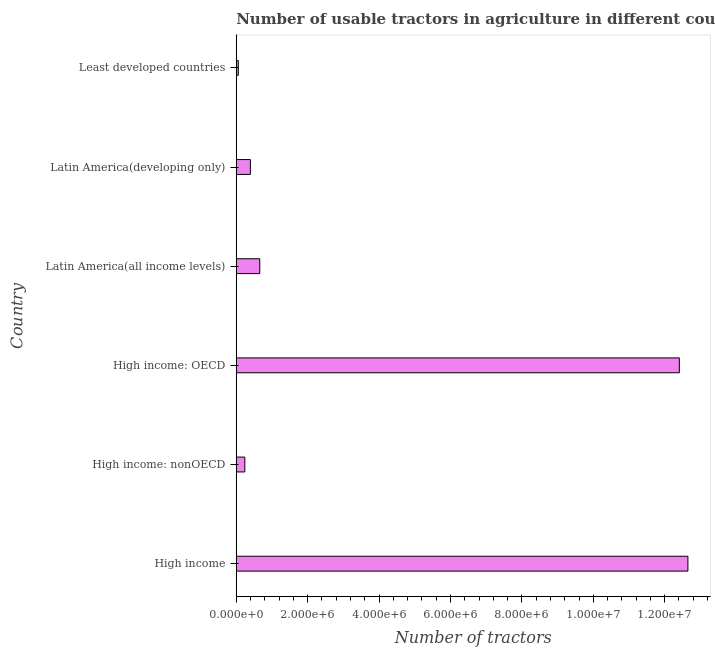Does the graph contain any zero values?
Make the answer very short. No. Does the graph contain grids?
Your response must be concise. No. What is the title of the graph?
Provide a succinct answer. Number of usable tractors in agriculture in different countries. What is the label or title of the X-axis?
Give a very brief answer. Number of tractors. What is the number of tractors in High income: nonOECD?
Offer a terse response. 2.40e+05. Across all countries, what is the maximum number of tractors?
Give a very brief answer. 1.26e+07. Across all countries, what is the minimum number of tractors?
Your response must be concise. 5.76e+04. In which country was the number of tractors maximum?
Your response must be concise. High income. In which country was the number of tractors minimum?
Provide a succinct answer. Least developed countries. What is the sum of the number of tractors?
Offer a very short reply. 2.64e+07. What is the difference between the number of tractors in High income: OECD and Latin America(all income levels)?
Provide a succinct answer. 1.18e+07. What is the average number of tractors per country?
Provide a short and direct response. 4.40e+06. What is the median number of tractors?
Your response must be concise. 5.27e+05. In how many countries, is the number of tractors greater than 400000 ?
Offer a very short reply. 3. What is the ratio of the number of tractors in High income: OECD to that in Latin America(developing only)?
Your response must be concise. 31.39. What is the difference between the highest and the second highest number of tractors?
Offer a terse response. 2.40e+05. What is the difference between the highest and the lowest number of tractors?
Provide a succinct answer. 1.26e+07. In how many countries, is the number of tractors greater than the average number of tractors taken over all countries?
Keep it short and to the point. 2. Are all the bars in the graph horizontal?
Ensure brevity in your answer.  Yes. How many countries are there in the graph?
Your answer should be compact. 6. Are the values on the major ticks of X-axis written in scientific E-notation?
Make the answer very short. Yes. What is the Number of tractors in High income?
Provide a short and direct response. 1.26e+07. What is the Number of tractors in High income: nonOECD?
Your answer should be very brief. 2.40e+05. What is the Number of tractors of High income: OECD?
Your response must be concise. 1.24e+07. What is the Number of tractors of Latin America(all income levels)?
Give a very brief answer. 6.59e+05. What is the Number of tractors of Latin America(developing only)?
Offer a very short reply. 3.95e+05. What is the Number of tractors in Least developed countries?
Provide a short and direct response. 5.76e+04. What is the difference between the Number of tractors in High income and High income: nonOECD?
Offer a very short reply. 1.24e+07. What is the difference between the Number of tractors in High income and High income: OECD?
Give a very brief answer. 2.40e+05. What is the difference between the Number of tractors in High income and Latin America(all income levels)?
Provide a short and direct response. 1.20e+07. What is the difference between the Number of tractors in High income and Latin America(developing only)?
Ensure brevity in your answer.  1.23e+07. What is the difference between the Number of tractors in High income and Least developed countries?
Provide a succinct answer. 1.26e+07. What is the difference between the Number of tractors in High income: nonOECD and High income: OECD?
Offer a very short reply. -1.22e+07. What is the difference between the Number of tractors in High income: nonOECD and Latin America(all income levels)?
Provide a short and direct response. -4.19e+05. What is the difference between the Number of tractors in High income: nonOECD and Latin America(developing only)?
Keep it short and to the point. -1.56e+05. What is the difference between the Number of tractors in High income: nonOECD and Least developed countries?
Give a very brief answer. 1.82e+05. What is the difference between the Number of tractors in High income: OECD and Latin America(all income levels)?
Your answer should be compact. 1.18e+07. What is the difference between the Number of tractors in High income: OECD and Latin America(developing only)?
Offer a terse response. 1.20e+07. What is the difference between the Number of tractors in High income: OECD and Least developed countries?
Provide a short and direct response. 1.24e+07. What is the difference between the Number of tractors in Latin America(all income levels) and Latin America(developing only)?
Give a very brief answer. 2.63e+05. What is the difference between the Number of tractors in Latin America(all income levels) and Least developed countries?
Provide a succinct answer. 6.01e+05. What is the difference between the Number of tractors in Latin America(developing only) and Least developed countries?
Offer a very short reply. 3.38e+05. What is the ratio of the Number of tractors in High income to that in High income: nonOECD?
Offer a very short reply. 52.77. What is the ratio of the Number of tractors in High income to that in High income: OECD?
Provide a succinct answer. 1.02. What is the ratio of the Number of tractors in High income to that in Latin America(all income levels)?
Your response must be concise. 19.2. What is the ratio of the Number of tractors in High income to that in Latin America(developing only)?
Ensure brevity in your answer.  32. What is the ratio of the Number of tractors in High income to that in Least developed countries?
Your answer should be very brief. 219.74. What is the ratio of the Number of tractors in High income: nonOECD to that in High income: OECD?
Your answer should be very brief. 0.02. What is the ratio of the Number of tractors in High income: nonOECD to that in Latin America(all income levels)?
Provide a succinct answer. 0.36. What is the ratio of the Number of tractors in High income: nonOECD to that in Latin America(developing only)?
Offer a very short reply. 0.61. What is the ratio of the Number of tractors in High income: nonOECD to that in Least developed countries?
Your answer should be compact. 4.16. What is the ratio of the Number of tractors in High income: OECD to that in Latin America(all income levels)?
Your response must be concise. 18.84. What is the ratio of the Number of tractors in High income: OECD to that in Latin America(developing only)?
Your response must be concise. 31.39. What is the ratio of the Number of tractors in High income: OECD to that in Least developed countries?
Ensure brevity in your answer.  215.58. What is the ratio of the Number of tractors in Latin America(all income levels) to that in Latin America(developing only)?
Your answer should be compact. 1.67. What is the ratio of the Number of tractors in Latin America(all income levels) to that in Least developed countries?
Keep it short and to the point. 11.44. What is the ratio of the Number of tractors in Latin America(developing only) to that in Least developed countries?
Offer a very short reply. 6.87. 